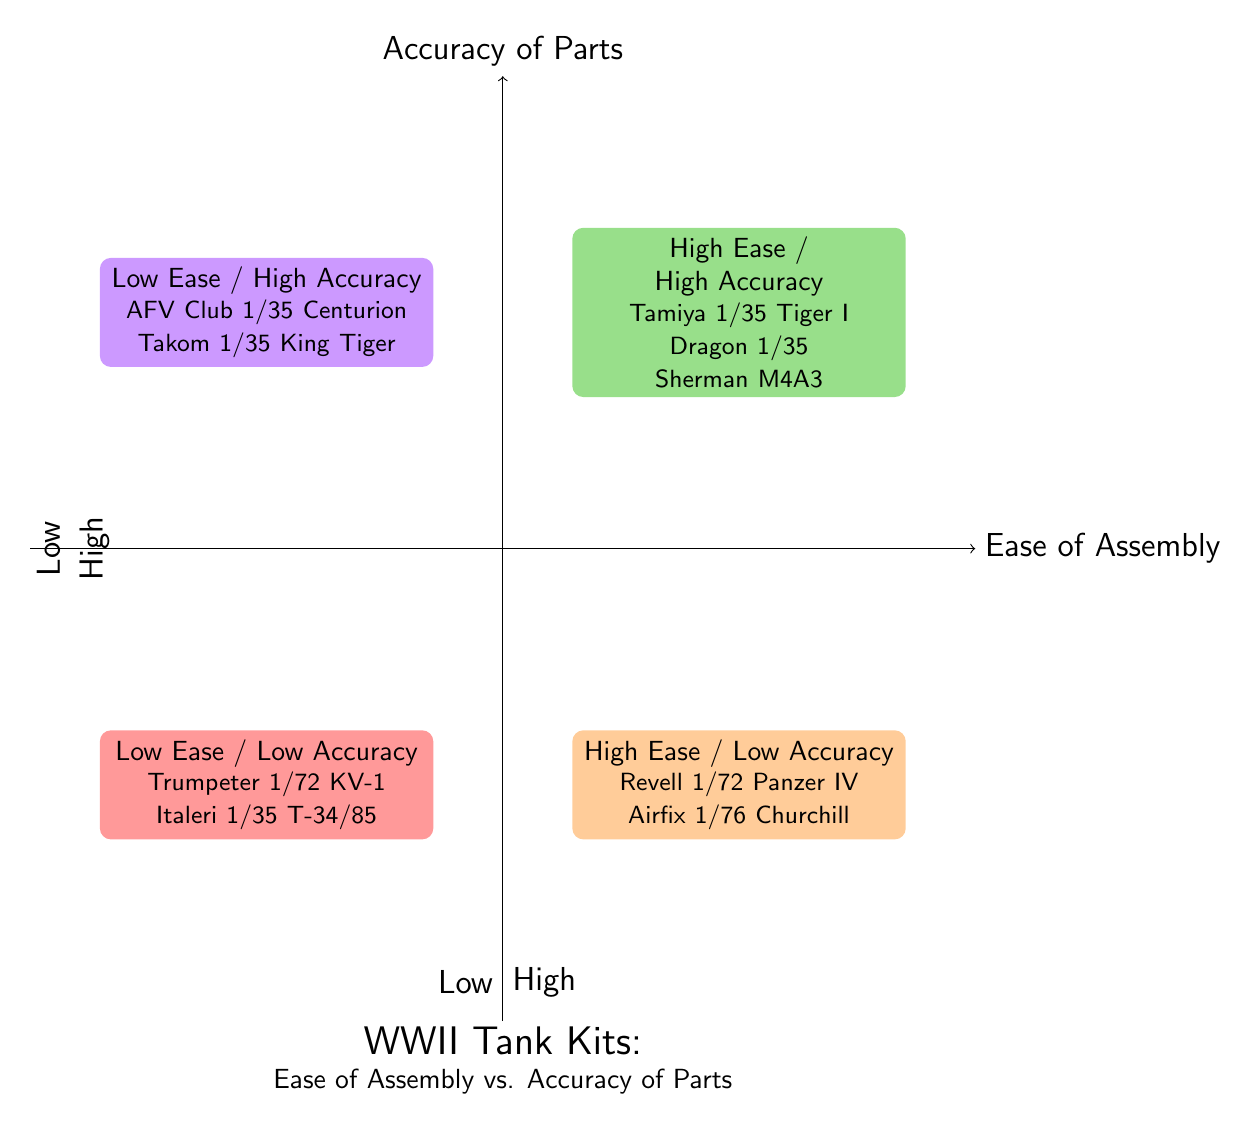What examples are in the High Ease of Assembly / High Accuracy quadrant? The question refers to the quadrant in the upper right section of the chart. By examining this section, we find the models listed as "Tamiya 1/35 Tiger I" and "Dragon Models 1/35 Sherman M4A3."
Answer: Tamiya 1/35 Tiger I, Dragon Models 1/35 Sherman M4A3 Which quadrant has the Revell 1/72 Panzer IV? The Revell 1/72 Panzer IV is located in the lower right quadrant, which is categorized as High Ease of Assembly and Low Accuracy.
Answer: High Ease / Low Accuracy How many examples are listed in the Low Ease of Assembly / Low Accuracy quadrant? By reviewing the lower left quadrant, we identify two examples provided: "Trumpeter 1/72 Soviet KV-1" and "Italeri 1/35 T-34/85." This totals two examples.
Answer: 2 What quadrant contains the AFV Club 1/35 Centurion Mk.5? The AFV Club 1/35 Centurion Mk.5 is situated in the upper left quadrant, designated as Low Ease of Assembly and High Accuracy.
Answer: Low Ease / High Accuracy Which models have Low Ease of Assembly? To determine this, we look in both upper left and lower left quadrants. The models listed are "AFV Club 1/35 Centurion Mk.5" and "Takom 1/35 King Tiger with full interior" from the Low Ease / High Accuracy quadrant; and "Trumpeter 1/72 Soviet KV-1" and "Italeri 1/35 T-34/85" from the Low Ease / Low Accuracy quadrant.
Answer: AFV Club 1/35 Centurion Mk.5, Takom 1/35 King Tiger with full interior, Trumpeter 1/72 Soviet KV-1, Italeri 1/35 T-34/85 Which model is mentioned in the quadrant that has High Ease of Assembly but Low Accuracy? In the quadrant positioned at the lower right, we find examples such as "Revell 1/72 Panzer IV" and "Airfix 1/76 Churchill Mk.VII." Thus, both models belong to this category.
Answer: Revell 1/72 Panzer IV, Airfix 1/76 Churchill Mk.VII 